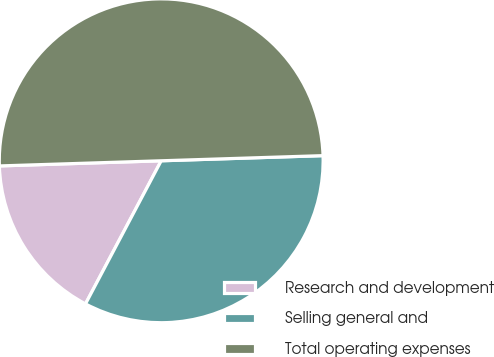Convert chart to OTSL. <chart><loc_0><loc_0><loc_500><loc_500><pie_chart><fcel>Research and development<fcel>Selling general and<fcel>Total operating expenses<nl><fcel>16.75%<fcel>33.25%<fcel>50.0%<nl></chart> 